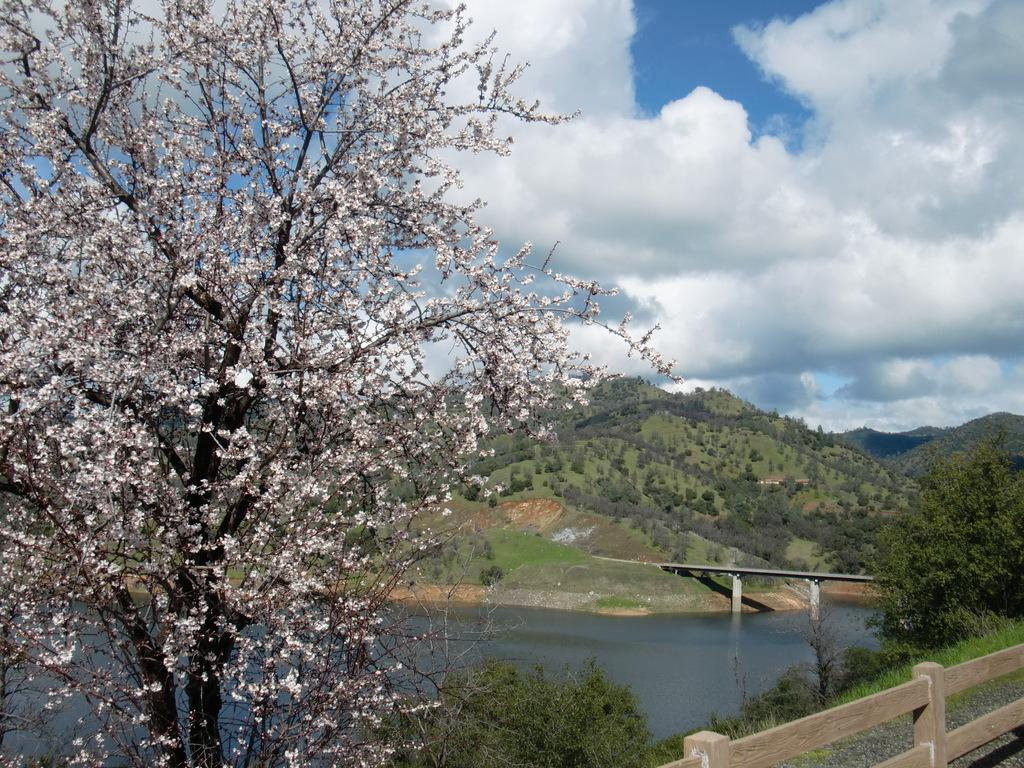What type of tree is in the left corner of the image? There is a tree with white flowers in the left corner of the image. What can be seen in the image besides the tree? Water is visible in the image. What structures can be seen in the background of the image? There is a bridge and mountains in the background of the image. What else is present in the background of the image? There are trees in the background of the image. What type of drug is being sold on the bridge in the image? There is no indication of any drug or drug sales in the image; it features a tree, water, and a bridge in a natural setting. 